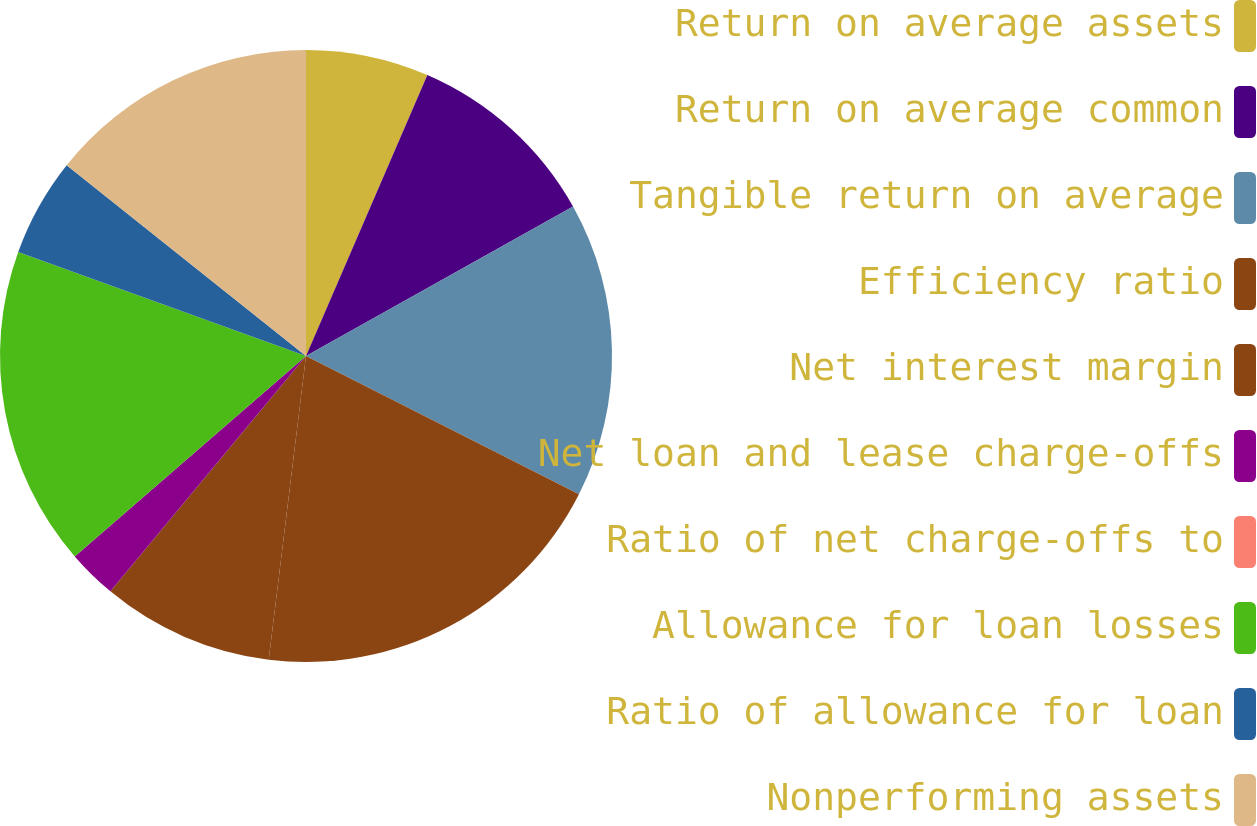Convert chart. <chart><loc_0><loc_0><loc_500><loc_500><pie_chart><fcel>Return on average assets<fcel>Return on average common<fcel>Tangible return on average<fcel>Efficiency ratio<fcel>Net interest margin<fcel>Net loan and lease charge-offs<fcel>Ratio of net charge-offs to<fcel>Allowance for loan losses<fcel>Ratio of allowance for loan<fcel>Nonperforming assets<nl><fcel>6.49%<fcel>10.39%<fcel>15.58%<fcel>19.48%<fcel>9.09%<fcel>2.6%<fcel>0.0%<fcel>16.88%<fcel>5.19%<fcel>14.29%<nl></chart> 